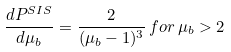Convert formula to latex. <formula><loc_0><loc_0><loc_500><loc_500>\frac { d P ^ { S I S } } { d \mu _ { b } } = \frac { 2 } { ( \mu _ { b } - 1 ) ^ { 3 } } \, f o r \, \mu _ { b } > 2</formula> 